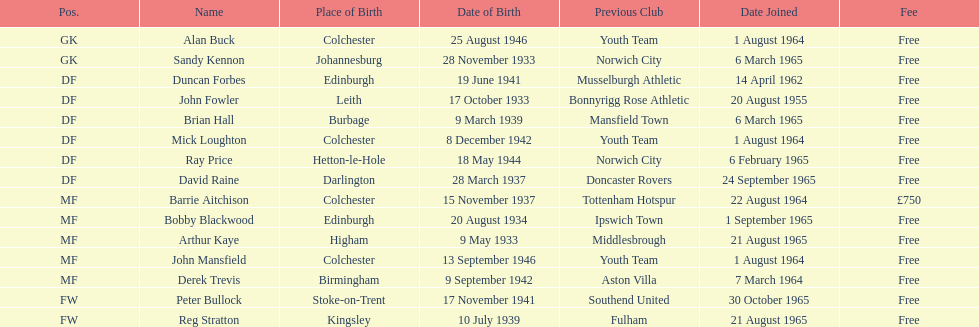Which team was ray price on before he started for this team? Norwich City. 